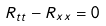<formula> <loc_0><loc_0><loc_500><loc_500>R _ { t t } - R _ { x x } = 0</formula> 